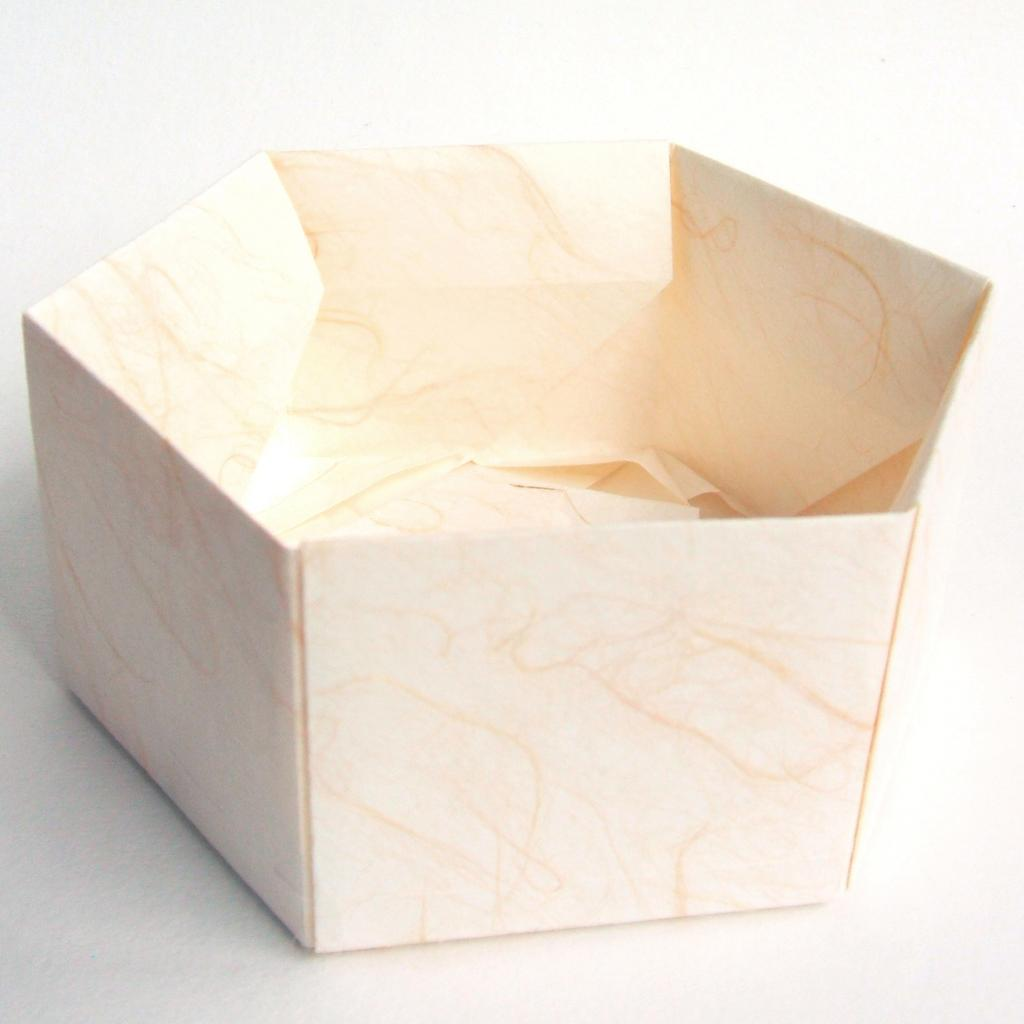What object is the main focus of the image? There is a parcel box in the image. What color is the background of the image? The background of the image is white. What songs can be heard playing from the parcel box in the image? There are no songs or sounds coming from the parcel box in the image. 